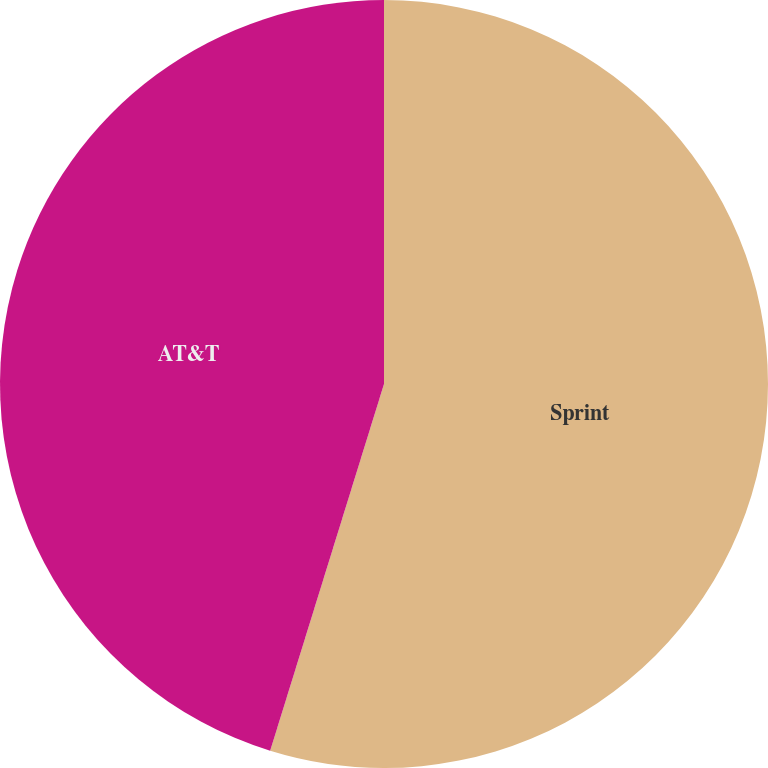<chart> <loc_0><loc_0><loc_500><loc_500><pie_chart><fcel>Sprint<fcel>AT&T<nl><fcel>54.79%<fcel>45.21%<nl></chart> 